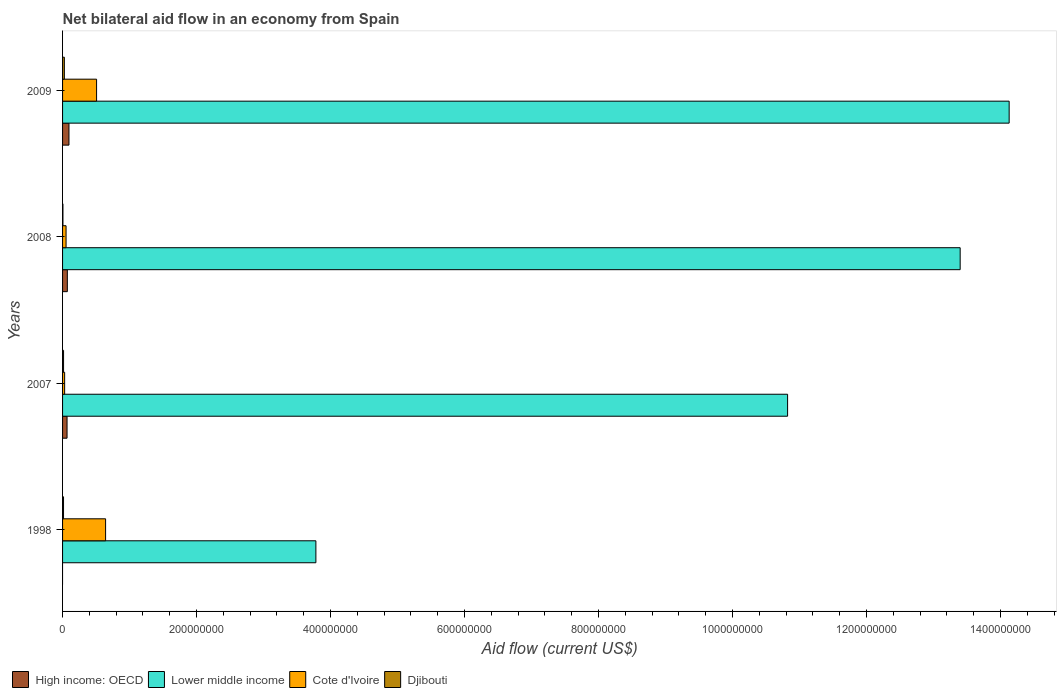Are the number of bars per tick equal to the number of legend labels?
Keep it short and to the point. No. Are the number of bars on each tick of the Y-axis equal?
Offer a very short reply. No. What is the net bilateral aid flow in Lower middle income in 2008?
Provide a succinct answer. 1.34e+09. Across all years, what is the maximum net bilateral aid flow in Djibouti?
Make the answer very short. 2.67e+06. Across all years, what is the minimum net bilateral aid flow in Djibouti?
Provide a succinct answer. 5.60e+05. In which year was the net bilateral aid flow in Cote d'Ivoire maximum?
Provide a short and direct response. 1998. What is the total net bilateral aid flow in Djibouti in the graph?
Your answer should be compact. 6.15e+06. What is the difference between the net bilateral aid flow in Cote d'Ivoire in 2007 and that in 2008?
Offer a very short reply. -2.14e+06. What is the difference between the net bilateral aid flow in High income: OECD in 2008 and the net bilateral aid flow in Djibouti in 1998?
Keep it short and to the point. 5.71e+06. What is the average net bilateral aid flow in Lower middle income per year?
Your answer should be very brief. 1.05e+09. In the year 1998, what is the difference between the net bilateral aid flow in Cote d'Ivoire and net bilateral aid flow in Djibouti?
Give a very brief answer. 6.28e+07. In how many years, is the net bilateral aid flow in Cote d'Ivoire greater than 240000000 US$?
Give a very brief answer. 0. What is the ratio of the net bilateral aid flow in High income: OECD in 2007 to that in 2008?
Offer a very short reply. 0.94. What is the difference between the highest and the second highest net bilateral aid flow in Lower middle income?
Your answer should be very brief. 7.31e+07. What is the difference between the highest and the lowest net bilateral aid flow in Cote d'Ivoire?
Ensure brevity in your answer.  6.11e+07. Is the sum of the net bilateral aid flow in Djibouti in 1998 and 2009 greater than the maximum net bilateral aid flow in Lower middle income across all years?
Make the answer very short. No. Is it the case that in every year, the sum of the net bilateral aid flow in High income: OECD and net bilateral aid flow in Djibouti is greater than the net bilateral aid flow in Cote d'Ivoire?
Ensure brevity in your answer.  No. Are all the bars in the graph horizontal?
Offer a terse response. Yes. How many years are there in the graph?
Make the answer very short. 4. What is the difference between two consecutive major ticks on the X-axis?
Ensure brevity in your answer.  2.00e+08. Does the graph contain any zero values?
Keep it short and to the point. Yes. How many legend labels are there?
Offer a very short reply. 4. How are the legend labels stacked?
Your response must be concise. Horizontal. What is the title of the graph?
Provide a succinct answer. Net bilateral aid flow in an economy from Spain. Does "Comoros" appear as one of the legend labels in the graph?
Your answer should be very brief. No. What is the label or title of the Y-axis?
Give a very brief answer. Years. What is the Aid flow (current US$) of Lower middle income in 1998?
Ensure brevity in your answer.  3.78e+08. What is the Aid flow (current US$) of Cote d'Ivoire in 1998?
Ensure brevity in your answer.  6.42e+07. What is the Aid flow (current US$) in Djibouti in 1998?
Offer a very short reply. 1.43e+06. What is the Aid flow (current US$) in High income: OECD in 2007?
Your response must be concise. 6.70e+06. What is the Aid flow (current US$) in Lower middle income in 2007?
Your response must be concise. 1.08e+09. What is the Aid flow (current US$) in Cote d'Ivoire in 2007?
Offer a very short reply. 3.09e+06. What is the Aid flow (current US$) of Djibouti in 2007?
Offer a terse response. 1.49e+06. What is the Aid flow (current US$) in High income: OECD in 2008?
Provide a short and direct response. 7.14e+06. What is the Aid flow (current US$) of Lower middle income in 2008?
Give a very brief answer. 1.34e+09. What is the Aid flow (current US$) of Cote d'Ivoire in 2008?
Your answer should be compact. 5.23e+06. What is the Aid flow (current US$) in Djibouti in 2008?
Make the answer very short. 5.60e+05. What is the Aid flow (current US$) in High income: OECD in 2009?
Ensure brevity in your answer.  9.56e+06. What is the Aid flow (current US$) in Lower middle income in 2009?
Give a very brief answer. 1.41e+09. What is the Aid flow (current US$) of Cote d'Ivoire in 2009?
Provide a succinct answer. 5.08e+07. What is the Aid flow (current US$) of Djibouti in 2009?
Provide a succinct answer. 2.67e+06. Across all years, what is the maximum Aid flow (current US$) of High income: OECD?
Provide a succinct answer. 9.56e+06. Across all years, what is the maximum Aid flow (current US$) in Lower middle income?
Ensure brevity in your answer.  1.41e+09. Across all years, what is the maximum Aid flow (current US$) in Cote d'Ivoire?
Provide a short and direct response. 6.42e+07. Across all years, what is the maximum Aid flow (current US$) of Djibouti?
Keep it short and to the point. 2.67e+06. Across all years, what is the minimum Aid flow (current US$) of High income: OECD?
Offer a very short reply. 0. Across all years, what is the minimum Aid flow (current US$) of Lower middle income?
Provide a short and direct response. 3.78e+08. Across all years, what is the minimum Aid flow (current US$) in Cote d'Ivoire?
Give a very brief answer. 3.09e+06. Across all years, what is the minimum Aid flow (current US$) in Djibouti?
Provide a short and direct response. 5.60e+05. What is the total Aid flow (current US$) in High income: OECD in the graph?
Your answer should be very brief. 2.34e+07. What is the total Aid flow (current US$) in Lower middle income in the graph?
Offer a very short reply. 4.21e+09. What is the total Aid flow (current US$) in Cote d'Ivoire in the graph?
Your response must be concise. 1.23e+08. What is the total Aid flow (current US$) in Djibouti in the graph?
Your response must be concise. 6.15e+06. What is the difference between the Aid flow (current US$) in Lower middle income in 1998 and that in 2007?
Make the answer very short. -7.04e+08. What is the difference between the Aid flow (current US$) of Cote d'Ivoire in 1998 and that in 2007?
Your answer should be very brief. 6.11e+07. What is the difference between the Aid flow (current US$) in Djibouti in 1998 and that in 2007?
Your response must be concise. -6.00e+04. What is the difference between the Aid flow (current US$) of Lower middle income in 1998 and that in 2008?
Make the answer very short. -9.62e+08. What is the difference between the Aid flow (current US$) in Cote d'Ivoire in 1998 and that in 2008?
Your answer should be compact. 5.90e+07. What is the difference between the Aid flow (current US$) in Djibouti in 1998 and that in 2008?
Make the answer very short. 8.70e+05. What is the difference between the Aid flow (current US$) in Lower middle income in 1998 and that in 2009?
Make the answer very short. -1.03e+09. What is the difference between the Aid flow (current US$) in Cote d'Ivoire in 1998 and that in 2009?
Provide a succinct answer. 1.34e+07. What is the difference between the Aid flow (current US$) of Djibouti in 1998 and that in 2009?
Offer a terse response. -1.24e+06. What is the difference between the Aid flow (current US$) in High income: OECD in 2007 and that in 2008?
Keep it short and to the point. -4.40e+05. What is the difference between the Aid flow (current US$) of Lower middle income in 2007 and that in 2008?
Keep it short and to the point. -2.58e+08. What is the difference between the Aid flow (current US$) of Cote d'Ivoire in 2007 and that in 2008?
Offer a very short reply. -2.14e+06. What is the difference between the Aid flow (current US$) in Djibouti in 2007 and that in 2008?
Offer a very short reply. 9.30e+05. What is the difference between the Aid flow (current US$) in High income: OECD in 2007 and that in 2009?
Give a very brief answer. -2.86e+06. What is the difference between the Aid flow (current US$) in Lower middle income in 2007 and that in 2009?
Provide a short and direct response. -3.31e+08. What is the difference between the Aid flow (current US$) in Cote d'Ivoire in 2007 and that in 2009?
Provide a short and direct response. -4.77e+07. What is the difference between the Aid flow (current US$) in Djibouti in 2007 and that in 2009?
Give a very brief answer. -1.18e+06. What is the difference between the Aid flow (current US$) in High income: OECD in 2008 and that in 2009?
Ensure brevity in your answer.  -2.42e+06. What is the difference between the Aid flow (current US$) of Lower middle income in 2008 and that in 2009?
Offer a terse response. -7.31e+07. What is the difference between the Aid flow (current US$) of Cote d'Ivoire in 2008 and that in 2009?
Provide a succinct answer. -4.55e+07. What is the difference between the Aid flow (current US$) of Djibouti in 2008 and that in 2009?
Offer a terse response. -2.11e+06. What is the difference between the Aid flow (current US$) of Lower middle income in 1998 and the Aid flow (current US$) of Cote d'Ivoire in 2007?
Ensure brevity in your answer.  3.75e+08. What is the difference between the Aid flow (current US$) in Lower middle income in 1998 and the Aid flow (current US$) in Djibouti in 2007?
Provide a succinct answer. 3.77e+08. What is the difference between the Aid flow (current US$) in Cote d'Ivoire in 1998 and the Aid flow (current US$) in Djibouti in 2007?
Offer a very short reply. 6.27e+07. What is the difference between the Aid flow (current US$) in Lower middle income in 1998 and the Aid flow (current US$) in Cote d'Ivoire in 2008?
Provide a succinct answer. 3.73e+08. What is the difference between the Aid flow (current US$) in Lower middle income in 1998 and the Aid flow (current US$) in Djibouti in 2008?
Ensure brevity in your answer.  3.78e+08. What is the difference between the Aid flow (current US$) in Cote d'Ivoire in 1998 and the Aid flow (current US$) in Djibouti in 2008?
Your answer should be very brief. 6.37e+07. What is the difference between the Aid flow (current US$) of Lower middle income in 1998 and the Aid flow (current US$) of Cote d'Ivoire in 2009?
Your answer should be compact. 3.27e+08. What is the difference between the Aid flow (current US$) in Lower middle income in 1998 and the Aid flow (current US$) in Djibouti in 2009?
Provide a succinct answer. 3.75e+08. What is the difference between the Aid flow (current US$) in Cote d'Ivoire in 1998 and the Aid flow (current US$) in Djibouti in 2009?
Make the answer very short. 6.16e+07. What is the difference between the Aid flow (current US$) of High income: OECD in 2007 and the Aid flow (current US$) of Lower middle income in 2008?
Your response must be concise. -1.33e+09. What is the difference between the Aid flow (current US$) in High income: OECD in 2007 and the Aid flow (current US$) in Cote d'Ivoire in 2008?
Your answer should be compact. 1.47e+06. What is the difference between the Aid flow (current US$) of High income: OECD in 2007 and the Aid flow (current US$) of Djibouti in 2008?
Provide a short and direct response. 6.14e+06. What is the difference between the Aid flow (current US$) of Lower middle income in 2007 and the Aid flow (current US$) of Cote d'Ivoire in 2008?
Offer a very short reply. 1.08e+09. What is the difference between the Aid flow (current US$) of Lower middle income in 2007 and the Aid flow (current US$) of Djibouti in 2008?
Keep it short and to the point. 1.08e+09. What is the difference between the Aid flow (current US$) in Cote d'Ivoire in 2007 and the Aid flow (current US$) in Djibouti in 2008?
Offer a very short reply. 2.53e+06. What is the difference between the Aid flow (current US$) of High income: OECD in 2007 and the Aid flow (current US$) of Lower middle income in 2009?
Your answer should be very brief. -1.41e+09. What is the difference between the Aid flow (current US$) of High income: OECD in 2007 and the Aid flow (current US$) of Cote d'Ivoire in 2009?
Make the answer very short. -4.41e+07. What is the difference between the Aid flow (current US$) in High income: OECD in 2007 and the Aid flow (current US$) in Djibouti in 2009?
Make the answer very short. 4.03e+06. What is the difference between the Aid flow (current US$) of Lower middle income in 2007 and the Aid flow (current US$) of Cote d'Ivoire in 2009?
Your answer should be very brief. 1.03e+09. What is the difference between the Aid flow (current US$) of Lower middle income in 2007 and the Aid flow (current US$) of Djibouti in 2009?
Provide a short and direct response. 1.08e+09. What is the difference between the Aid flow (current US$) of High income: OECD in 2008 and the Aid flow (current US$) of Lower middle income in 2009?
Provide a succinct answer. -1.41e+09. What is the difference between the Aid flow (current US$) in High income: OECD in 2008 and the Aid flow (current US$) in Cote d'Ivoire in 2009?
Provide a succinct answer. -4.36e+07. What is the difference between the Aid flow (current US$) in High income: OECD in 2008 and the Aid flow (current US$) in Djibouti in 2009?
Make the answer very short. 4.47e+06. What is the difference between the Aid flow (current US$) of Lower middle income in 2008 and the Aid flow (current US$) of Cote d'Ivoire in 2009?
Offer a very short reply. 1.29e+09. What is the difference between the Aid flow (current US$) in Lower middle income in 2008 and the Aid flow (current US$) in Djibouti in 2009?
Your response must be concise. 1.34e+09. What is the difference between the Aid flow (current US$) of Cote d'Ivoire in 2008 and the Aid flow (current US$) of Djibouti in 2009?
Provide a succinct answer. 2.56e+06. What is the average Aid flow (current US$) in High income: OECD per year?
Your answer should be compact. 5.85e+06. What is the average Aid flow (current US$) of Lower middle income per year?
Provide a succinct answer. 1.05e+09. What is the average Aid flow (current US$) of Cote d'Ivoire per year?
Ensure brevity in your answer.  3.08e+07. What is the average Aid flow (current US$) of Djibouti per year?
Your answer should be compact. 1.54e+06. In the year 1998, what is the difference between the Aid flow (current US$) of Lower middle income and Aid flow (current US$) of Cote d'Ivoire?
Offer a terse response. 3.14e+08. In the year 1998, what is the difference between the Aid flow (current US$) of Lower middle income and Aid flow (current US$) of Djibouti?
Make the answer very short. 3.77e+08. In the year 1998, what is the difference between the Aid flow (current US$) of Cote d'Ivoire and Aid flow (current US$) of Djibouti?
Provide a succinct answer. 6.28e+07. In the year 2007, what is the difference between the Aid flow (current US$) in High income: OECD and Aid flow (current US$) in Lower middle income?
Give a very brief answer. -1.08e+09. In the year 2007, what is the difference between the Aid flow (current US$) in High income: OECD and Aid flow (current US$) in Cote d'Ivoire?
Ensure brevity in your answer.  3.61e+06. In the year 2007, what is the difference between the Aid flow (current US$) of High income: OECD and Aid flow (current US$) of Djibouti?
Your answer should be very brief. 5.21e+06. In the year 2007, what is the difference between the Aid flow (current US$) in Lower middle income and Aid flow (current US$) in Cote d'Ivoire?
Your answer should be very brief. 1.08e+09. In the year 2007, what is the difference between the Aid flow (current US$) of Lower middle income and Aid flow (current US$) of Djibouti?
Offer a very short reply. 1.08e+09. In the year 2007, what is the difference between the Aid flow (current US$) in Cote d'Ivoire and Aid flow (current US$) in Djibouti?
Ensure brevity in your answer.  1.60e+06. In the year 2008, what is the difference between the Aid flow (current US$) in High income: OECD and Aid flow (current US$) in Lower middle income?
Ensure brevity in your answer.  -1.33e+09. In the year 2008, what is the difference between the Aid flow (current US$) in High income: OECD and Aid flow (current US$) in Cote d'Ivoire?
Your answer should be very brief. 1.91e+06. In the year 2008, what is the difference between the Aid flow (current US$) in High income: OECD and Aid flow (current US$) in Djibouti?
Your response must be concise. 6.58e+06. In the year 2008, what is the difference between the Aid flow (current US$) in Lower middle income and Aid flow (current US$) in Cote d'Ivoire?
Provide a succinct answer. 1.33e+09. In the year 2008, what is the difference between the Aid flow (current US$) of Lower middle income and Aid flow (current US$) of Djibouti?
Offer a very short reply. 1.34e+09. In the year 2008, what is the difference between the Aid flow (current US$) of Cote d'Ivoire and Aid flow (current US$) of Djibouti?
Offer a terse response. 4.67e+06. In the year 2009, what is the difference between the Aid flow (current US$) in High income: OECD and Aid flow (current US$) in Lower middle income?
Provide a short and direct response. -1.40e+09. In the year 2009, what is the difference between the Aid flow (current US$) of High income: OECD and Aid flow (current US$) of Cote d'Ivoire?
Offer a terse response. -4.12e+07. In the year 2009, what is the difference between the Aid flow (current US$) of High income: OECD and Aid flow (current US$) of Djibouti?
Make the answer very short. 6.89e+06. In the year 2009, what is the difference between the Aid flow (current US$) of Lower middle income and Aid flow (current US$) of Cote d'Ivoire?
Provide a succinct answer. 1.36e+09. In the year 2009, what is the difference between the Aid flow (current US$) of Lower middle income and Aid flow (current US$) of Djibouti?
Provide a short and direct response. 1.41e+09. In the year 2009, what is the difference between the Aid flow (current US$) in Cote d'Ivoire and Aid flow (current US$) in Djibouti?
Offer a very short reply. 4.81e+07. What is the ratio of the Aid flow (current US$) of Lower middle income in 1998 to that in 2007?
Ensure brevity in your answer.  0.35. What is the ratio of the Aid flow (current US$) of Cote d'Ivoire in 1998 to that in 2007?
Your answer should be very brief. 20.78. What is the ratio of the Aid flow (current US$) in Djibouti in 1998 to that in 2007?
Make the answer very short. 0.96. What is the ratio of the Aid flow (current US$) in Lower middle income in 1998 to that in 2008?
Provide a succinct answer. 0.28. What is the ratio of the Aid flow (current US$) in Cote d'Ivoire in 1998 to that in 2008?
Make the answer very short. 12.28. What is the ratio of the Aid flow (current US$) of Djibouti in 1998 to that in 2008?
Your response must be concise. 2.55. What is the ratio of the Aid flow (current US$) of Lower middle income in 1998 to that in 2009?
Your answer should be compact. 0.27. What is the ratio of the Aid flow (current US$) in Cote d'Ivoire in 1998 to that in 2009?
Your answer should be compact. 1.26. What is the ratio of the Aid flow (current US$) of Djibouti in 1998 to that in 2009?
Your response must be concise. 0.54. What is the ratio of the Aid flow (current US$) of High income: OECD in 2007 to that in 2008?
Ensure brevity in your answer.  0.94. What is the ratio of the Aid flow (current US$) in Lower middle income in 2007 to that in 2008?
Give a very brief answer. 0.81. What is the ratio of the Aid flow (current US$) of Cote d'Ivoire in 2007 to that in 2008?
Your answer should be compact. 0.59. What is the ratio of the Aid flow (current US$) in Djibouti in 2007 to that in 2008?
Provide a succinct answer. 2.66. What is the ratio of the Aid flow (current US$) in High income: OECD in 2007 to that in 2009?
Offer a very short reply. 0.7. What is the ratio of the Aid flow (current US$) of Lower middle income in 2007 to that in 2009?
Provide a succinct answer. 0.77. What is the ratio of the Aid flow (current US$) of Cote d'Ivoire in 2007 to that in 2009?
Offer a very short reply. 0.06. What is the ratio of the Aid flow (current US$) in Djibouti in 2007 to that in 2009?
Provide a succinct answer. 0.56. What is the ratio of the Aid flow (current US$) of High income: OECD in 2008 to that in 2009?
Offer a terse response. 0.75. What is the ratio of the Aid flow (current US$) in Lower middle income in 2008 to that in 2009?
Offer a very short reply. 0.95. What is the ratio of the Aid flow (current US$) of Cote d'Ivoire in 2008 to that in 2009?
Ensure brevity in your answer.  0.1. What is the ratio of the Aid flow (current US$) in Djibouti in 2008 to that in 2009?
Your answer should be compact. 0.21. What is the difference between the highest and the second highest Aid flow (current US$) of High income: OECD?
Make the answer very short. 2.42e+06. What is the difference between the highest and the second highest Aid flow (current US$) of Lower middle income?
Give a very brief answer. 7.31e+07. What is the difference between the highest and the second highest Aid flow (current US$) in Cote d'Ivoire?
Your answer should be very brief. 1.34e+07. What is the difference between the highest and the second highest Aid flow (current US$) of Djibouti?
Provide a succinct answer. 1.18e+06. What is the difference between the highest and the lowest Aid flow (current US$) of High income: OECD?
Your response must be concise. 9.56e+06. What is the difference between the highest and the lowest Aid flow (current US$) in Lower middle income?
Provide a succinct answer. 1.03e+09. What is the difference between the highest and the lowest Aid flow (current US$) of Cote d'Ivoire?
Keep it short and to the point. 6.11e+07. What is the difference between the highest and the lowest Aid flow (current US$) of Djibouti?
Keep it short and to the point. 2.11e+06. 